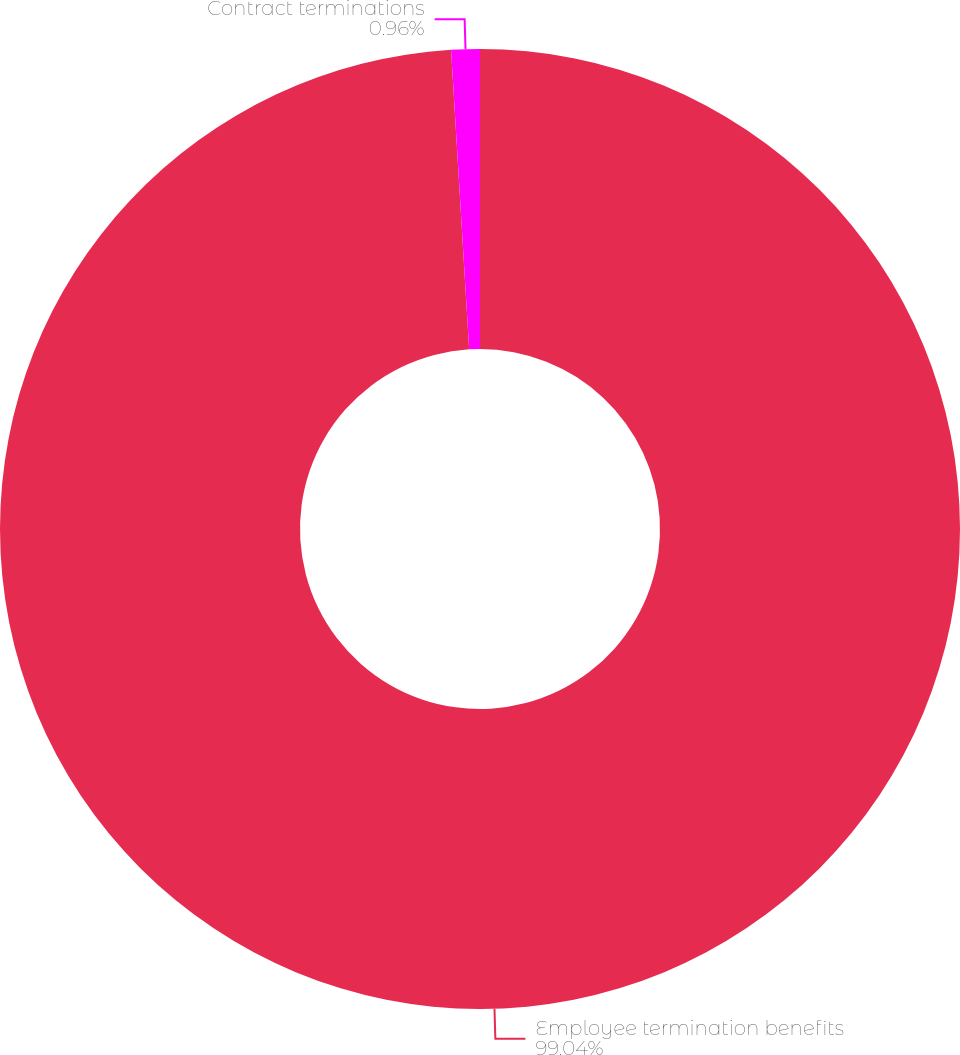<chart> <loc_0><loc_0><loc_500><loc_500><pie_chart><fcel>Employee termination benefits<fcel>Contract terminations<nl><fcel>99.04%<fcel>0.96%<nl></chart> 